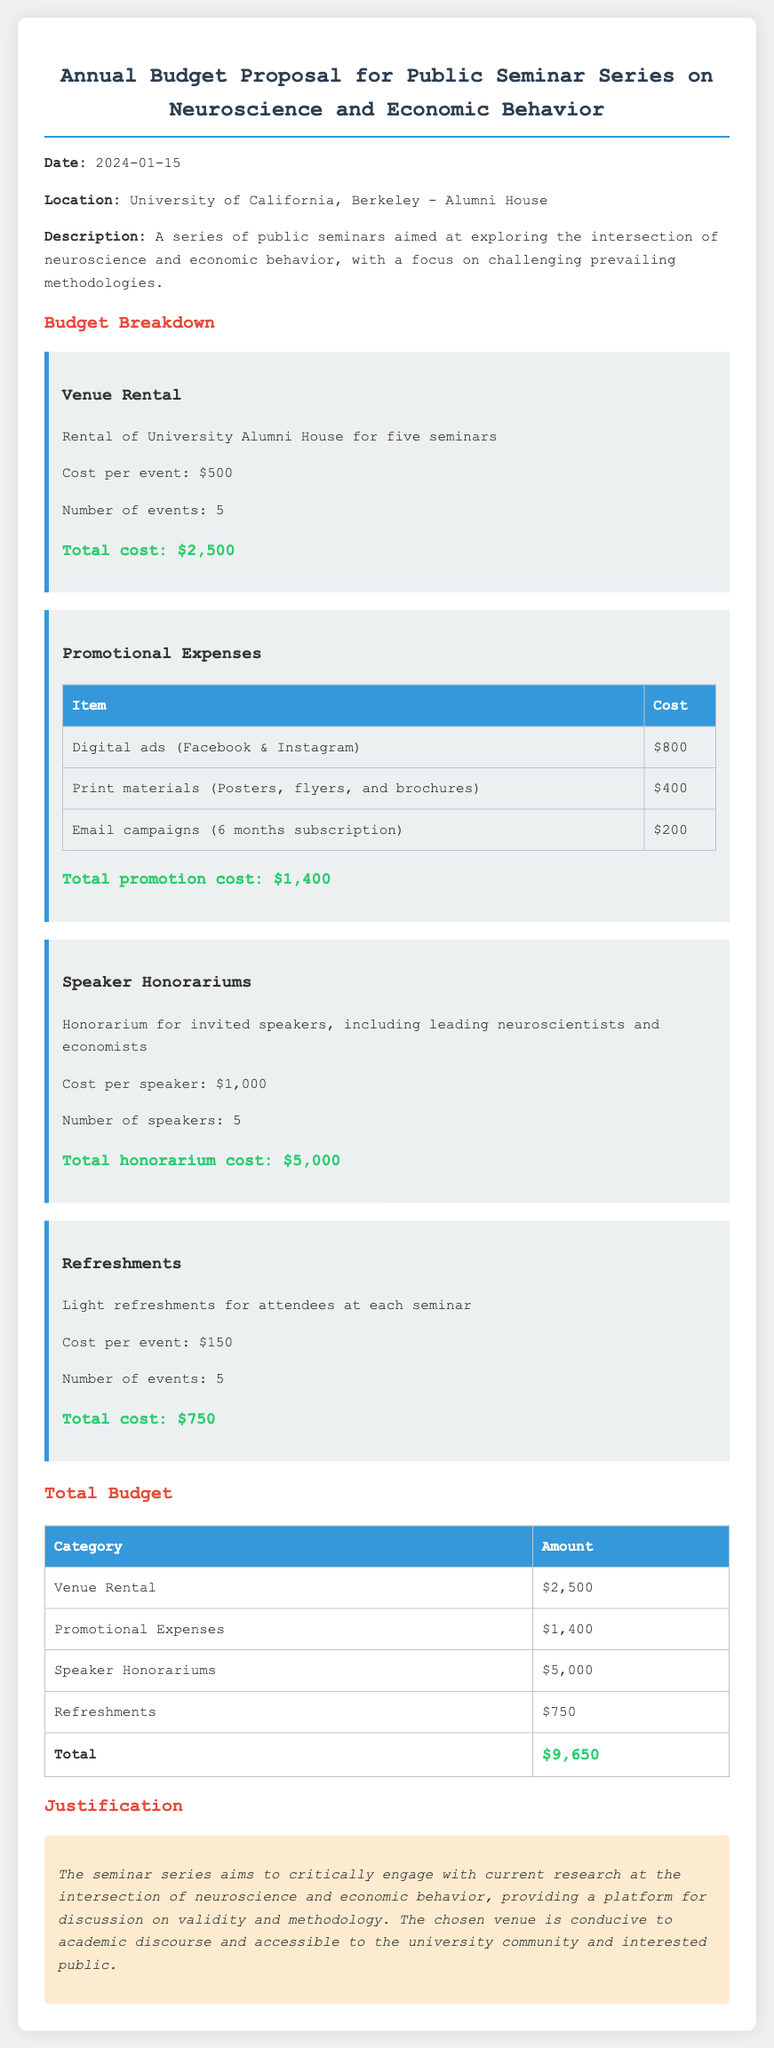what is the total budget? The total budget is the sum of all costs in the budget breakdown, which is $2,500 + $1,400 + $5,000 + $750 = $9,650.
Answer: $9,650 how many speakers are invited for the seminars? The budget states that there are 5 speakers invited for the seminars, with a cost of $1,000 per speaker.
Answer: 5 what is the cost per event for venue rental? The document mentions that the cost per event for venue rental is $500 for five seminars.
Answer: $500 which location is hosting the seminar series? The document specifies that the seminars will take place at the University of California, Berkeley - Alumni House.
Answer: University of California, Berkeley - Alumni House how much is allocated for digital ads? The promotional expenses include $800 for digital ads (Facebook & Instagram).
Answer: $800 what is the total honorarium cost for speakers? The total honorarium cost is calculated by multiplying the number of speakers (5) by the cost per speaker ($1,000), resulting in $5,000.
Answer: $5,000 what type of materials are included in the promotional expenses? The promotional expenses include print materials such as posters, flyers, and brochures, with a cost of $400.
Answer: Print materials (Posters, flyers, and brochures) how much is budgeted for refreshments per event? The document states that the cost for refreshments per event is $150, and this is for five seminars.
Answer: $150 what is the justification for the seminar series? The justification explains that the series aims to critically engage with current research, providing a platform for discussion on validity and methodology.
Answer: The seminar series aims to critically engage with current research at the intersection of neuroscience and economic behavior 